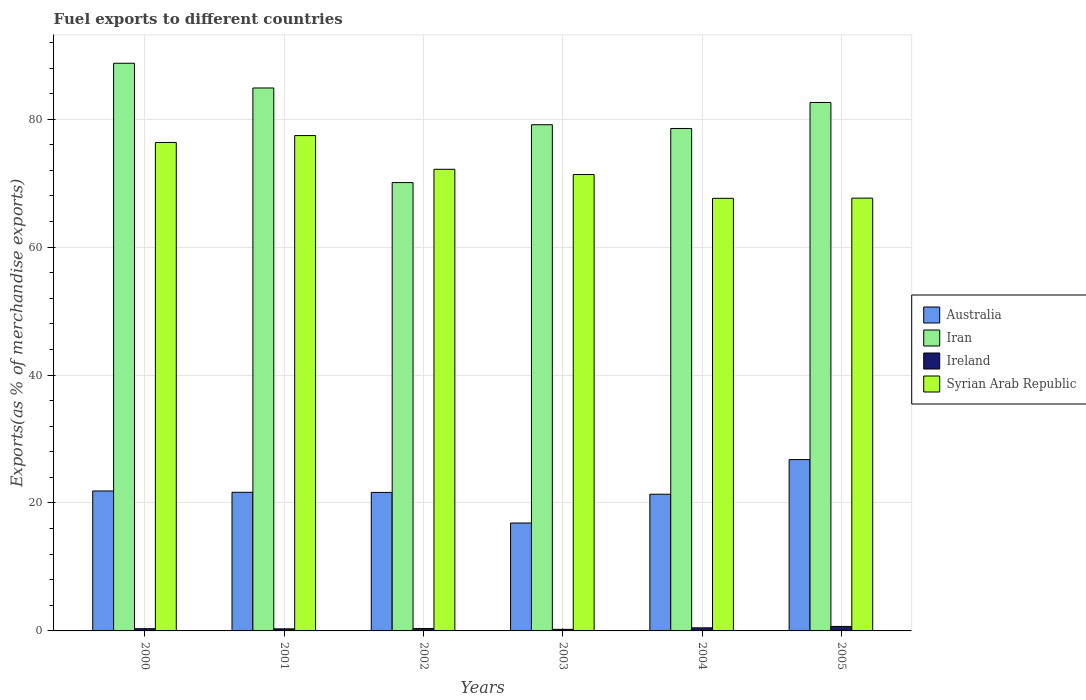How many groups of bars are there?
Offer a very short reply. 6. Are the number of bars per tick equal to the number of legend labels?
Your answer should be very brief. Yes. How many bars are there on the 4th tick from the right?
Offer a very short reply. 4. What is the label of the 6th group of bars from the left?
Keep it short and to the point. 2005. What is the percentage of exports to different countries in Ireland in 2002?
Keep it short and to the point. 0.38. Across all years, what is the maximum percentage of exports to different countries in Australia?
Your response must be concise. 26.79. Across all years, what is the minimum percentage of exports to different countries in Iran?
Offer a terse response. 70.09. In which year was the percentage of exports to different countries in Iran maximum?
Make the answer very short. 2000. What is the total percentage of exports to different countries in Syrian Arab Republic in the graph?
Make the answer very short. 432.6. What is the difference between the percentage of exports to different countries in Iran in 2002 and that in 2003?
Make the answer very short. -9.04. What is the difference between the percentage of exports to different countries in Syrian Arab Republic in 2000 and the percentage of exports to different countries in Ireland in 2002?
Your answer should be very brief. 75.98. What is the average percentage of exports to different countries in Syrian Arab Republic per year?
Your response must be concise. 72.1. In the year 2000, what is the difference between the percentage of exports to different countries in Iran and percentage of exports to different countries in Ireland?
Offer a very short reply. 88.4. In how many years, is the percentage of exports to different countries in Australia greater than 44 %?
Keep it short and to the point. 0. What is the ratio of the percentage of exports to different countries in Ireland in 2004 to that in 2005?
Provide a short and direct response. 0.69. Is the percentage of exports to different countries in Australia in 2001 less than that in 2004?
Offer a terse response. No. What is the difference between the highest and the second highest percentage of exports to different countries in Ireland?
Provide a succinct answer. 0.22. What is the difference between the highest and the lowest percentage of exports to different countries in Iran?
Your answer should be compact. 18.65. What does the 2nd bar from the left in 2000 represents?
Ensure brevity in your answer.  Iran. What does the 1st bar from the right in 2003 represents?
Make the answer very short. Syrian Arab Republic. Is it the case that in every year, the sum of the percentage of exports to different countries in Iran and percentage of exports to different countries in Australia is greater than the percentage of exports to different countries in Ireland?
Your answer should be compact. Yes. How many bars are there?
Provide a succinct answer. 24. Are all the bars in the graph horizontal?
Offer a terse response. No. Are the values on the major ticks of Y-axis written in scientific E-notation?
Ensure brevity in your answer.  No. Does the graph contain any zero values?
Provide a short and direct response. No. Where does the legend appear in the graph?
Provide a short and direct response. Center right. What is the title of the graph?
Make the answer very short. Fuel exports to different countries. Does "Nepal" appear as one of the legend labels in the graph?
Provide a short and direct response. No. What is the label or title of the Y-axis?
Your response must be concise. Exports(as % of merchandise exports). What is the Exports(as % of merchandise exports) in Australia in 2000?
Your answer should be very brief. 21.88. What is the Exports(as % of merchandise exports) of Iran in 2000?
Provide a succinct answer. 88.74. What is the Exports(as % of merchandise exports) in Ireland in 2000?
Offer a very short reply. 0.35. What is the Exports(as % of merchandise exports) of Syrian Arab Republic in 2000?
Give a very brief answer. 76.36. What is the Exports(as % of merchandise exports) in Australia in 2001?
Give a very brief answer. 21.67. What is the Exports(as % of merchandise exports) in Iran in 2001?
Your answer should be compact. 84.88. What is the Exports(as % of merchandise exports) in Ireland in 2001?
Your response must be concise. 0.32. What is the Exports(as % of merchandise exports) in Syrian Arab Republic in 2001?
Provide a succinct answer. 77.44. What is the Exports(as % of merchandise exports) of Australia in 2002?
Offer a very short reply. 21.65. What is the Exports(as % of merchandise exports) in Iran in 2002?
Give a very brief answer. 70.09. What is the Exports(as % of merchandise exports) in Ireland in 2002?
Your response must be concise. 0.38. What is the Exports(as % of merchandise exports) in Syrian Arab Republic in 2002?
Provide a succinct answer. 72.17. What is the Exports(as % of merchandise exports) in Australia in 2003?
Your answer should be very brief. 16.87. What is the Exports(as % of merchandise exports) of Iran in 2003?
Provide a succinct answer. 79.13. What is the Exports(as % of merchandise exports) in Ireland in 2003?
Your answer should be very brief. 0.24. What is the Exports(as % of merchandise exports) in Syrian Arab Republic in 2003?
Give a very brief answer. 71.35. What is the Exports(as % of merchandise exports) in Australia in 2004?
Give a very brief answer. 21.37. What is the Exports(as % of merchandise exports) in Iran in 2004?
Keep it short and to the point. 78.55. What is the Exports(as % of merchandise exports) of Ireland in 2004?
Your answer should be very brief. 0.48. What is the Exports(as % of merchandise exports) in Syrian Arab Republic in 2004?
Offer a very short reply. 67.63. What is the Exports(as % of merchandise exports) in Australia in 2005?
Offer a terse response. 26.79. What is the Exports(as % of merchandise exports) of Iran in 2005?
Your answer should be compact. 82.61. What is the Exports(as % of merchandise exports) in Ireland in 2005?
Give a very brief answer. 0.7. What is the Exports(as % of merchandise exports) of Syrian Arab Republic in 2005?
Keep it short and to the point. 67.66. Across all years, what is the maximum Exports(as % of merchandise exports) in Australia?
Your response must be concise. 26.79. Across all years, what is the maximum Exports(as % of merchandise exports) of Iran?
Your answer should be very brief. 88.74. Across all years, what is the maximum Exports(as % of merchandise exports) of Ireland?
Provide a succinct answer. 0.7. Across all years, what is the maximum Exports(as % of merchandise exports) of Syrian Arab Republic?
Ensure brevity in your answer.  77.44. Across all years, what is the minimum Exports(as % of merchandise exports) in Australia?
Ensure brevity in your answer.  16.87. Across all years, what is the minimum Exports(as % of merchandise exports) in Iran?
Offer a terse response. 70.09. Across all years, what is the minimum Exports(as % of merchandise exports) of Ireland?
Provide a succinct answer. 0.24. Across all years, what is the minimum Exports(as % of merchandise exports) in Syrian Arab Republic?
Provide a succinct answer. 67.63. What is the total Exports(as % of merchandise exports) in Australia in the graph?
Keep it short and to the point. 130.23. What is the total Exports(as % of merchandise exports) in Iran in the graph?
Offer a terse response. 484. What is the total Exports(as % of merchandise exports) of Ireland in the graph?
Give a very brief answer. 2.48. What is the total Exports(as % of merchandise exports) in Syrian Arab Republic in the graph?
Provide a short and direct response. 432.6. What is the difference between the Exports(as % of merchandise exports) of Australia in 2000 and that in 2001?
Ensure brevity in your answer.  0.21. What is the difference between the Exports(as % of merchandise exports) of Iran in 2000 and that in 2001?
Your answer should be compact. 3.86. What is the difference between the Exports(as % of merchandise exports) of Ireland in 2000 and that in 2001?
Offer a terse response. 0.02. What is the difference between the Exports(as % of merchandise exports) of Syrian Arab Republic in 2000 and that in 2001?
Ensure brevity in your answer.  -1.08. What is the difference between the Exports(as % of merchandise exports) in Australia in 2000 and that in 2002?
Make the answer very short. 0.23. What is the difference between the Exports(as % of merchandise exports) in Iran in 2000 and that in 2002?
Your answer should be very brief. 18.65. What is the difference between the Exports(as % of merchandise exports) of Ireland in 2000 and that in 2002?
Keep it short and to the point. -0.04. What is the difference between the Exports(as % of merchandise exports) in Syrian Arab Republic in 2000 and that in 2002?
Your response must be concise. 4.19. What is the difference between the Exports(as % of merchandise exports) of Australia in 2000 and that in 2003?
Your answer should be very brief. 5.01. What is the difference between the Exports(as % of merchandise exports) of Iran in 2000 and that in 2003?
Offer a terse response. 9.61. What is the difference between the Exports(as % of merchandise exports) in Ireland in 2000 and that in 2003?
Make the answer very short. 0.1. What is the difference between the Exports(as % of merchandise exports) in Syrian Arab Republic in 2000 and that in 2003?
Make the answer very short. 5.01. What is the difference between the Exports(as % of merchandise exports) of Australia in 2000 and that in 2004?
Give a very brief answer. 0.51. What is the difference between the Exports(as % of merchandise exports) of Iran in 2000 and that in 2004?
Offer a terse response. 10.2. What is the difference between the Exports(as % of merchandise exports) in Ireland in 2000 and that in 2004?
Give a very brief answer. -0.14. What is the difference between the Exports(as % of merchandise exports) in Syrian Arab Republic in 2000 and that in 2004?
Offer a very short reply. 8.73. What is the difference between the Exports(as % of merchandise exports) in Australia in 2000 and that in 2005?
Ensure brevity in your answer.  -4.91. What is the difference between the Exports(as % of merchandise exports) of Iran in 2000 and that in 2005?
Your answer should be compact. 6.13. What is the difference between the Exports(as % of merchandise exports) in Ireland in 2000 and that in 2005?
Give a very brief answer. -0.35. What is the difference between the Exports(as % of merchandise exports) of Syrian Arab Republic in 2000 and that in 2005?
Make the answer very short. 8.71. What is the difference between the Exports(as % of merchandise exports) in Australia in 2001 and that in 2002?
Keep it short and to the point. 0.02. What is the difference between the Exports(as % of merchandise exports) of Iran in 2001 and that in 2002?
Make the answer very short. 14.79. What is the difference between the Exports(as % of merchandise exports) of Ireland in 2001 and that in 2002?
Give a very brief answer. -0.06. What is the difference between the Exports(as % of merchandise exports) in Syrian Arab Republic in 2001 and that in 2002?
Your response must be concise. 5.27. What is the difference between the Exports(as % of merchandise exports) of Australia in 2001 and that in 2003?
Provide a succinct answer. 4.8. What is the difference between the Exports(as % of merchandise exports) in Iran in 2001 and that in 2003?
Your answer should be compact. 5.74. What is the difference between the Exports(as % of merchandise exports) in Ireland in 2001 and that in 2003?
Make the answer very short. 0.08. What is the difference between the Exports(as % of merchandise exports) in Syrian Arab Republic in 2001 and that in 2003?
Keep it short and to the point. 6.09. What is the difference between the Exports(as % of merchandise exports) of Australia in 2001 and that in 2004?
Offer a very short reply. 0.3. What is the difference between the Exports(as % of merchandise exports) of Iran in 2001 and that in 2004?
Your response must be concise. 6.33. What is the difference between the Exports(as % of merchandise exports) in Ireland in 2001 and that in 2004?
Your answer should be very brief. -0.16. What is the difference between the Exports(as % of merchandise exports) of Syrian Arab Republic in 2001 and that in 2004?
Provide a short and direct response. 9.81. What is the difference between the Exports(as % of merchandise exports) in Australia in 2001 and that in 2005?
Give a very brief answer. -5.11. What is the difference between the Exports(as % of merchandise exports) of Iran in 2001 and that in 2005?
Provide a short and direct response. 2.27. What is the difference between the Exports(as % of merchandise exports) in Ireland in 2001 and that in 2005?
Give a very brief answer. -0.38. What is the difference between the Exports(as % of merchandise exports) in Syrian Arab Republic in 2001 and that in 2005?
Give a very brief answer. 9.78. What is the difference between the Exports(as % of merchandise exports) in Australia in 2002 and that in 2003?
Your response must be concise. 4.78. What is the difference between the Exports(as % of merchandise exports) of Iran in 2002 and that in 2003?
Your answer should be very brief. -9.04. What is the difference between the Exports(as % of merchandise exports) in Ireland in 2002 and that in 2003?
Your answer should be very brief. 0.14. What is the difference between the Exports(as % of merchandise exports) of Syrian Arab Republic in 2002 and that in 2003?
Ensure brevity in your answer.  0.82. What is the difference between the Exports(as % of merchandise exports) of Australia in 2002 and that in 2004?
Offer a terse response. 0.28. What is the difference between the Exports(as % of merchandise exports) of Iran in 2002 and that in 2004?
Provide a short and direct response. -8.46. What is the difference between the Exports(as % of merchandise exports) of Ireland in 2002 and that in 2004?
Your response must be concise. -0.1. What is the difference between the Exports(as % of merchandise exports) in Syrian Arab Republic in 2002 and that in 2004?
Provide a succinct answer. 4.54. What is the difference between the Exports(as % of merchandise exports) in Australia in 2002 and that in 2005?
Your response must be concise. -5.13. What is the difference between the Exports(as % of merchandise exports) in Iran in 2002 and that in 2005?
Ensure brevity in your answer.  -12.52. What is the difference between the Exports(as % of merchandise exports) in Ireland in 2002 and that in 2005?
Give a very brief answer. -0.32. What is the difference between the Exports(as % of merchandise exports) of Syrian Arab Republic in 2002 and that in 2005?
Ensure brevity in your answer.  4.51. What is the difference between the Exports(as % of merchandise exports) in Australia in 2003 and that in 2004?
Your response must be concise. -4.5. What is the difference between the Exports(as % of merchandise exports) in Iran in 2003 and that in 2004?
Offer a terse response. 0.59. What is the difference between the Exports(as % of merchandise exports) in Ireland in 2003 and that in 2004?
Provide a short and direct response. -0.24. What is the difference between the Exports(as % of merchandise exports) of Syrian Arab Republic in 2003 and that in 2004?
Ensure brevity in your answer.  3.72. What is the difference between the Exports(as % of merchandise exports) of Australia in 2003 and that in 2005?
Your answer should be compact. -9.91. What is the difference between the Exports(as % of merchandise exports) in Iran in 2003 and that in 2005?
Provide a short and direct response. -3.48. What is the difference between the Exports(as % of merchandise exports) of Ireland in 2003 and that in 2005?
Your answer should be very brief. -0.46. What is the difference between the Exports(as % of merchandise exports) in Syrian Arab Republic in 2003 and that in 2005?
Provide a short and direct response. 3.69. What is the difference between the Exports(as % of merchandise exports) in Australia in 2004 and that in 2005?
Ensure brevity in your answer.  -5.41. What is the difference between the Exports(as % of merchandise exports) in Iran in 2004 and that in 2005?
Ensure brevity in your answer.  -4.06. What is the difference between the Exports(as % of merchandise exports) in Ireland in 2004 and that in 2005?
Give a very brief answer. -0.22. What is the difference between the Exports(as % of merchandise exports) in Syrian Arab Republic in 2004 and that in 2005?
Keep it short and to the point. -0.03. What is the difference between the Exports(as % of merchandise exports) of Australia in 2000 and the Exports(as % of merchandise exports) of Iran in 2001?
Your answer should be very brief. -63. What is the difference between the Exports(as % of merchandise exports) of Australia in 2000 and the Exports(as % of merchandise exports) of Ireland in 2001?
Provide a short and direct response. 21.56. What is the difference between the Exports(as % of merchandise exports) in Australia in 2000 and the Exports(as % of merchandise exports) in Syrian Arab Republic in 2001?
Make the answer very short. -55.56. What is the difference between the Exports(as % of merchandise exports) in Iran in 2000 and the Exports(as % of merchandise exports) in Ireland in 2001?
Your answer should be very brief. 88.42. What is the difference between the Exports(as % of merchandise exports) of Iran in 2000 and the Exports(as % of merchandise exports) of Syrian Arab Republic in 2001?
Keep it short and to the point. 11.31. What is the difference between the Exports(as % of merchandise exports) in Ireland in 2000 and the Exports(as % of merchandise exports) in Syrian Arab Republic in 2001?
Offer a very short reply. -77.09. What is the difference between the Exports(as % of merchandise exports) of Australia in 2000 and the Exports(as % of merchandise exports) of Iran in 2002?
Your response must be concise. -48.21. What is the difference between the Exports(as % of merchandise exports) of Australia in 2000 and the Exports(as % of merchandise exports) of Ireland in 2002?
Keep it short and to the point. 21.5. What is the difference between the Exports(as % of merchandise exports) of Australia in 2000 and the Exports(as % of merchandise exports) of Syrian Arab Republic in 2002?
Ensure brevity in your answer.  -50.29. What is the difference between the Exports(as % of merchandise exports) in Iran in 2000 and the Exports(as % of merchandise exports) in Ireland in 2002?
Your answer should be compact. 88.36. What is the difference between the Exports(as % of merchandise exports) in Iran in 2000 and the Exports(as % of merchandise exports) in Syrian Arab Republic in 2002?
Keep it short and to the point. 16.58. What is the difference between the Exports(as % of merchandise exports) in Ireland in 2000 and the Exports(as % of merchandise exports) in Syrian Arab Republic in 2002?
Your answer should be compact. -71.82. What is the difference between the Exports(as % of merchandise exports) in Australia in 2000 and the Exports(as % of merchandise exports) in Iran in 2003?
Offer a very short reply. -57.25. What is the difference between the Exports(as % of merchandise exports) in Australia in 2000 and the Exports(as % of merchandise exports) in Ireland in 2003?
Keep it short and to the point. 21.64. What is the difference between the Exports(as % of merchandise exports) in Australia in 2000 and the Exports(as % of merchandise exports) in Syrian Arab Republic in 2003?
Keep it short and to the point. -49.47. What is the difference between the Exports(as % of merchandise exports) in Iran in 2000 and the Exports(as % of merchandise exports) in Ireland in 2003?
Ensure brevity in your answer.  88.5. What is the difference between the Exports(as % of merchandise exports) of Iran in 2000 and the Exports(as % of merchandise exports) of Syrian Arab Republic in 2003?
Keep it short and to the point. 17.4. What is the difference between the Exports(as % of merchandise exports) of Ireland in 2000 and the Exports(as % of merchandise exports) of Syrian Arab Republic in 2003?
Provide a short and direct response. -71. What is the difference between the Exports(as % of merchandise exports) of Australia in 2000 and the Exports(as % of merchandise exports) of Iran in 2004?
Offer a very short reply. -56.67. What is the difference between the Exports(as % of merchandise exports) of Australia in 2000 and the Exports(as % of merchandise exports) of Ireland in 2004?
Your answer should be compact. 21.4. What is the difference between the Exports(as % of merchandise exports) in Australia in 2000 and the Exports(as % of merchandise exports) in Syrian Arab Republic in 2004?
Keep it short and to the point. -45.75. What is the difference between the Exports(as % of merchandise exports) in Iran in 2000 and the Exports(as % of merchandise exports) in Ireland in 2004?
Provide a succinct answer. 88.26. What is the difference between the Exports(as % of merchandise exports) of Iran in 2000 and the Exports(as % of merchandise exports) of Syrian Arab Republic in 2004?
Your answer should be compact. 21.11. What is the difference between the Exports(as % of merchandise exports) of Ireland in 2000 and the Exports(as % of merchandise exports) of Syrian Arab Republic in 2004?
Offer a very short reply. -67.28. What is the difference between the Exports(as % of merchandise exports) of Australia in 2000 and the Exports(as % of merchandise exports) of Iran in 2005?
Offer a terse response. -60.73. What is the difference between the Exports(as % of merchandise exports) in Australia in 2000 and the Exports(as % of merchandise exports) in Ireland in 2005?
Give a very brief answer. 21.18. What is the difference between the Exports(as % of merchandise exports) of Australia in 2000 and the Exports(as % of merchandise exports) of Syrian Arab Republic in 2005?
Make the answer very short. -45.78. What is the difference between the Exports(as % of merchandise exports) of Iran in 2000 and the Exports(as % of merchandise exports) of Ireland in 2005?
Provide a short and direct response. 88.04. What is the difference between the Exports(as % of merchandise exports) in Iran in 2000 and the Exports(as % of merchandise exports) in Syrian Arab Republic in 2005?
Provide a succinct answer. 21.09. What is the difference between the Exports(as % of merchandise exports) in Ireland in 2000 and the Exports(as % of merchandise exports) in Syrian Arab Republic in 2005?
Your answer should be very brief. -67.31. What is the difference between the Exports(as % of merchandise exports) in Australia in 2001 and the Exports(as % of merchandise exports) in Iran in 2002?
Ensure brevity in your answer.  -48.42. What is the difference between the Exports(as % of merchandise exports) of Australia in 2001 and the Exports(as % of merchandise exports) of Ireland in 2002?
Keep it short and to the point. 21.29. What is the difference between the Exports(as % of merchandise exports) in Australia in 2001 and the Exports(as % of merchandise exports) in Syrian Arab Republic in 2002?
Your answer should be very brief. -50.5. What is the difference between the Exports(as % of merchandise exports) of Iran in 2001 and the Exports(as % of merchandise exports) of Ireland in 2002?
Provide a short and direct response. 84.49. What is the difference between the Exports(as % of merchandise exports) of Iran in 2001 and the Exports(as % of merchandise exports) of Syrian Arab Republic in 2002?
Ensure brevity in your answer.  12.71. What is the difference between the Exports(as % of merchandise exports) in Ireland in 2001 and the Exports(as % of merchandise exports) in Syrian Arab Republic in 2002?
Offer a terse response. -71.84. What is the difference between the Exports(as % of merchandise exports) of Australia in 2001 and the Exports(as % of merchandise exports) of Iran in 2003?
Your answer should be compact. -57.46. What is the difference between the Exports(as % of merchandise exports) in Australia in 2001 and the Exports(as % of merchandise exports) in Ireland in 2003?
Provide a succinct answer. 21.43. What is the difference between the Exports(as % of merchandise exports) of Australia in 2001 and the Exports(as % of merchandise exports) of Syrian Arab Republic in 2003?
Your answer should be very brief. -49.68. What is the difference between the Exports(as % of merchandise exports) of Iran in 2001 and the Exports(as % of merchandise exports) of Ireland in 2003?
Offer a terse response. 84.63. What is the difference between the Exports(as % of merchandise exports) of Iran in 2001 and the Exports(as % of merchandise exports) of Syrian Arab Republic in 2003?
Make the answer very short. 13.53. What is the difference between the Exports(as % of merchandise exports) in Ireland in 2001 and the Exports(as % of merchandise exports) in Syrian Arab Republic in 2003?
Ensure brevity in your answer.  -71.02. What is the difference between the Exports(as % of merchandise exports) in Australia in 2001 and the Exports(as % of merchandise exports) in Iran in 2004?
Provide a short and direct response. -56.88. What is the difference between the Exports(as % of merchandise exports) of Australia in 2001 and the Exports(as % of merchandise exports) of Ireland in 2004?
Give a very brief answer. 21.19. What is the difference between the Exports(as % of merchandise exports) in Australia in 2001 and the Exports(as % of merchandise exports) in Syrian Arab Republic in 2004?
Ensure brevity in your answer.  -45.96. What is the difference between the Exports(as % of merchandise exports) in Iran in 2001 and the Exports(as % of merchandise exports) in Ireland in 2004?
Provide a short and direct response. 84.4. What is the difference between the Exports(as % of merchandise exports) in Iran in 2001 and the Exports(as % of merchandise exports) in Syrian Arab Republic in 2004?
Your response must be concise. 17.25. What is the difference between the Exports(as % of merchandise exports) in Ireland in 2001 and the Exports(as % of merchandise exports) in Syrian Arab Republic in 2004?
Give a very brief answer. -67.31. What is the difference between the Exports(as % of merchandise exports) in Australia in 2001 and the Exports(as % of merchandise exports) in Iran in 2005?
Give a very brief answer. -60.94. What is the difference between the Exports(as % of merchandise exports) in Australia in 2001 and the Exports(as % of merchandise exports) in Ireland in 2005?
Keep it short and to the point. 20.97. What is the difference between the Exports(as % of merchandise exports) in Australia in 2001 and the Exports(as % of merchandise exports) in Syrian Arab Republic in 2005?
Provide a succinct answer. -45.99. What is the difference between the Exports(as % of merchandise exports) of Iran in 2001 and the Exports(as % of merchandise exports) of Ireland in 2005?
Give a very brief answer. 84.18. What is the difference between the Exports(as % of merchandise exports) in Iran in 2001 and the Exports(as % of merchandise exports) in Syrian Arab Republic in 2005?
Your response must be concise. 17.22. What is the difference between the Exports(as % of merchandise exports) in Ireland in 2001 and the Exports(as % of merchandise exports) in Syrian Arab Republic in 2005?
Offer a very short reply. -67.33. What is the difference between the Exports(as % of merchandise exports) in Australia in 2002 and the Exports(as % of merchandise exports) in Iran in 2003?
Your answer should be compact. -57.48. What is the difference between the Exports(as % of merchandise exports) in Australia in 2002 and the Exports(as % of merchandise exports) in Ireland in 2003?
Ensure brevity in your answer.  21.41. What is the difference between the Exports(as % of merchandise exports) in Australia in 2002 and the Exports(as % of merchandise exports) in Syrian Arab Republic in 2003?
Your response must be concise. -49.69. What is the difference between the Exports(as % of merchandise exports) in Iran in 2002 and the Exports(as % of merchandise exports) in Ireland in 2003?
Make the answer very short. 69.85. What is the difference between the Exports(as % of merchandise exports) in Iran in 2002 and the Exports(as % of merchandise exports) in Syrian Arab Republic in 2003?
Provide a short and direct response. -1.26. What is the difference between the Exports(as % of merchandise exports) in Ireland in 2002 and the Exports(as % of merchandise exports) in Syrian Arab Republic in 2003?
Ensure brevity in your answer.  -70.96. What is the difference between the Exports(as % of merchandise exports) of Australia in 2002 and the Exports(as % of merchandise exports) of Iran in 2004?
Your response must be concise. -56.89. What is the difference between the Exports(as % of merchandise exports) in Australia in 2002 and the Exports(as % of merchandise exports) in Ireland in 2004?
Make the answer very short. 21.17. What is the difference between the Exports(as % of merchandise exports) of Australia in 2002 and the Exports(as % of merchandise exports) of Syrian Arab Republic in 2004?
Provide a succinct answer. -45.98. What is the difference between the Exports(as % of merchandise exports) in Iran in 2002 and the Exports(as % of merchandise exports) in Ireland in 2004?
Your response must be concise. 69.61. What is the difference between the Exports(as % of merchandise exports) in Iran in 2002 and the Exports(as % of merchandise exports) in Syrian Arab Republic in 2004?
Your answer should be very brief. 2.46. What is the difference between the Exports(as % of merchandise exports) of Ireland in 2002 and the Exports(as % of merchandise exports) of Syrian Arab Republic in 2004?
Ensure brevity in your answer.  -67.25. What is the difference between the Exports(as % of merchandise exports) in Australia in 2002 and the Exports(as % of merchandise exports) in Iran in 2005?
Give a very brief answer. -60.96. What is the difference between the Exports(as % of merchandise exports) in Australia in 2002 and the Exports(as % of merchandise exports) in Ireland in 2005?
Provide a succinct answer. 20.95. What is the difference between the Exports(as % of merchandise exports) of Australia in 2002 and the Exports(as % of merchandise exports) of Syrian Arab Republic in 2005?
Your response must be concise. -46. What is the difference between the Exports(as % of merchandise exports) in Iran in 2002 and the Exports(as % of merchandise exports) in Ireland in 2005?
Offer a terse response. 69.39. What is the difference between the Exports(as % of merchandise exports) in Iran in 2002 and the Exports(as % of merchandise exports) in Syrian Arab Republic in 2005?
Ensure brevity in your answer.  2.43. What is the difference between the Exports(as % of merchandise exports) in Ireland in 2002 and the Exports(as % of merchandise exports) in Syrian Arab Republic in 2005?
Provide a short and direct response. -67.27. What is the difference between the Exports(as % of merchandise exports) of Australia in 2003 and the Exports(as % of merchandise exports) of Iran in 2004?
Keep it short and to the point. -61.68. What is the difference between the Exports(as % of merchandise exports) of Australia in 2003 and the Exports(as % of merchandise exports) of Ireland in 2004?
Provide a succinct answer. 16.39. What is the difference between the Exports(as % of merchandise exports) of Australia in 2003 and the Exports(as % of merchandise exports) of Syrian Arab Republic in 2004?
Provide a short and direct response. -50.76. What is the difference between the Exports(as % of merchandise exports) in Iran in 2003 and the Exports(as % of merchandise exports) in Ireland in 2004?
Provide a succinct answer. 78.65. What is the difference between the Exports(as % of merchandise exports) of Iran in 2003 and the Exports(as % of merchandise exports) of Syrian Arab Republic in 2004?
Provide a short and direct response. 11.5. What is the difference between the Exports(as % of merchandise exports) in Ireland in 2003 and the Exports(as % of merchandise exports) in Syrian Arab Republic in 2004?
Your answer should be compact. -67.38. What is the difference between the Exports(as % of merchandise exports) of Australia in 2003 and the Exports(as % of merchandise exports) of Iran in 2005?
Offer a very short reply. -65.74. What is the difference between the Exports(as % of merchandise exports) of Australia in 2003 and the Exports(as % of merchandise exports) of Ireland in 2005?
Provide a succinct answer. 16.17. What is the difference between the Exports(as % of merchandise exports) of Australia in 2003 and the Exports(as % of merchandise exports) of Syrian Arab Republic in 2005?
Your answer should be very brief. -50.79. What is the difference between the Exports(as % of merchandise exports) in Iran in 2003 and the Exports(as % of merchandise exports) in Ireland in 2005?
Keep it short and to the point. 78.43. What is the difference between the Exports(as % of merchandise exports) of Iran in 2003 and the Exports(as % of merchandise exports) of Syrian Arab Republic in 2005?
Provide a short and direct response. 11.48. What is the difference between the Exports(as % of merchandise exports) of Ireland in 2003 and the Exports(as % of merchandise exports) of Syrian Arab Republic in 2005?
Your answer should be very brief. -67.41. What is the difference between the Exports(as % of merchandise exports) in Australia in 2004 and the Exports(as % of merchandise exports) in Iran in 2005?
Make the answer very short. -61.24. What is the difference between the Exports(as % of merchandise exports) of Australia in 2004 and the Exports(as % of merchandise exports) of Ireland in 2005?
Provide a short and direct response. 20.67. What is the difference between the Exports(as % of merchandise exports) of Australia in 2004 and the Exports(as % of merchandise exports) of Syrian Arab Republic in 2005?
Give a very brief answer. -46.28. What is the difference between the Exports(as % of merchandise exports) of Iran in 2004 and the Exports(as % of merchandise exports) of Ireland in 2005?
Provide a short and direct response. 77.85. What is the difference between the Exports(as % of merchandise exports) in Iran in 2004 and the Exports(as % of merchandise exports) in Syrian Arab Republic in 2005?
Provide a short and direct response. 10.89. What is the difference between the Exports(as % of merchandise exports) of Ireland in 2004 and the Exports(as % of merchandise exports) of Syrian Arab Republic in 2005?
Your answer should be compact. -67.17. What is the average Exports(as % of merchandise exports) of Australia per year?
Make the answer very short. 21.71. What is the average Exports(as % of merchandise exports) of Iran per year?
Give a very brief answer. 80.67. What is the average Exports(as % of merchandise exports) in Ireland per year?
Provide a succinct answer. 0.41. What is the average Exports(as % of merchandise exports) in Syrian Arab Republic per year?
Your answer should be compact. 72.1. In the year 2000, what is the difference between the Exports(as % of merchandise exports) of Australia and Exports(as % of merchandise exports) of Iran?
Provide a short and direct response. -66.86. In the year 2000, what is the difference between the Exports(as % of merchandise exports) in Australia and Exports(as % of merchandise exports) in Ireland?
Offer a terse response. 21.53. In the year 2000, what is the difference between the Exports(as % of merchandise exports) in Australia and Exports(as % of merchandise exports) in Syrian Arab Republic?
Offer a terse response. -54.48. In the year 2000, what is the difference between the Exports(as % of merchandise exports) in Iran and Exports(as % of merchandise exports) in Ireland?
Offer a very short reply. 88.4. In the year 2000, what is the difference between the Exports(as % of merchandise exports) of Iran and Exports(as % of merchandise exports) of Syrian Arab Republic?
Make the answer very short. 12.38. In the year 2000, what is the difference between the Exports(as % of merchandise exports) of Ireland and Exports(as % of merchandise exports) of Syrian Arab Republic?
Offer a terse response. -76.02. In the year 2001, what is the difference between the Exports(as % of merchandise exports) in Australia and Exports(as % of merchandise exports) in Iran?
Offer a terse response. -63.21. In the year 2001, what is the difference between the Exports(as % of merchandise exports) of Australia and Exports(as % of merchandise exports) of Ireland?
Provide a short and direct response. 21.35. In the year 2001, what is the difference between the Exports(as % of merchandise exports) in Australia and Exports(as % of merchandise exports) in Syrian Arab Republic?
Make the answer very short. -55.77. In the year 2001, what is the difference between the Exports(as % of merchandise exports) of Iran and Exports(as % of merchandise exports) of Ireland?
Offer a very short reply. 84.55. In the year 2001, what is the difference between the Exports(as % of merchandise exports) of Iran and Exports(as % of merchandise exports) of Syrian Arab Republic?
Keep it short and to the point. 7.44. In the year 2001, what is the difference between the Exports(as % of merchandise exports) of Ireland and Exports(as % of merchandise exports) of Syrian Arab Republic?
Your answer should be compact. -77.11. In the year 2002, what is the difference between the Exports(as % of merchandise exports) of Australia and Exports(as % of merchandise exports) of Iran?
Your answer should be compact. -48.44. In the year 2002, what is the difference between the Exports(as % of merchandise exports) in Australia and Exports(as % of merchandise exports) in Ireland?
Give a very brief answer. 21.27. In the year 2002, what is the difference between the Exports(as % of merchandise exports) in Australia and Exports(as % of merchandise exports) in Syrian Arab Republic?
Your answer should be compact. -50.51. In the year 2002, what is the difference between the Exports(as % of merchandise exports) in Iran and Exports(as % of merchandise exports) in Ireland?
Keep it short and to the point. 69.71. In the year 2002, what is the difference between the Exports(as % of merchandise exports) of Iran and Exports(as % of merchandise exports) of Syrian Arab Republic?
Make the answer very short. -2.08. In the year 2002, what is the difference between the Exports(as % of merchandise exports) of Ireland and Exports(as % of merchandise exports) of Syrian Arab Republic?
Offer a terse response. -71.78. In the year 2003, what is the difference between the Exports(as % of merchandise exports) of Australia and Exports(as % of merchandise exports) of Iran?
Provide a succinct answer. -62.26. In the year 2003, what is the difference between the Exports(as % of merchandise exports) in Australia and Exports(as % of merchandise exports) in Ireland?
Offer a terse response. 16.63. In the year 2003, what is the difference between the Exports(as % of merchandise exports) of Australia and Exports(as % of merchandise exports) of Syrian Arab Republic?
Offer a very short reply. -54.48. In the year 2003, what is the difference between the Exports(as % of merchandise exports) in Iran and Exports(as % of merchandise exports) in Ireland?
Your response must be concise. 78.89. In the year 2003, what is the difference between the Exports(as % of merchandise exports) in Iran and Exports(as % of merchandise exports) in Syrian Arab Republic?
Offer a very short reply. 7.79. In the year 2003, what is the difference between the Exports(as % of merchandise exports) in Ireland and Exports(as % of merchandise exports) in Syrian Arab Republic?
Ensure brevity in your answer.  -71.1. In the year 2004, what is the difference between the Exports(as % of merchandise exports) in Australia and Exports(as % of merchandise exports) in Iran?
Give a very brief answer. -57.17. In the year 2004, what is the difference between the Exports(as % of merchandise exports) of Australia and Exports(as % of merchandise exports) of Ireland?
Your answer should be very brief. 20.89. In the year 2004, what is the difference between the Exports(as % of merchandise exports) of Australia and Exports(as % of merchandise exports) of Syrian Arab Republic?
Ensure brevity in your answer.  -46.26. In the year 2004, what is the difference between the Exports(as % of merchandise exports) in Iran and Exports(as % of merchandise exports) in Ireland?
Provide a short and direct response. 78.06. In the year 2004, what is the difference between the Exports(as % of merchandise exports) in Iran and Exports(as % of merchandise exports) in Syrian Arab Republic?
Ensure brevity in your answer.  10.92. In the year 2004, what is the difference between the Exports(as % of merchandise exports) of Ireland and Exports(as % of merchandise exports) of Syrian Arab Republic?
Your answer should be very brief. -67.15. In the year 2005, what is the difference between the Exports(as % of merchandise exports) of Australia and Exports(as % of merchandise exports) of Iran?
Provide a short and direct response. -55.83. In the year 2005, what is the difference between the Exports(as % of merchandise exports) in Australia and Exports(as % of merchandise exports) in Ireland?
Offer a terse response. 26.08. In the year 2005, what is the difference between the Exports(as % of merchandise exports) in Australia and Exports(as % of merchandise exports) in Syrian Arab Republic?
Give a very brief answer. -40.87. In the year 2005, what is the difference between the Exports(as % of merchandise exports) in Iran and Exports(as % of merchandise exports) in Ireland?
Make the answer very short. 81.91. In the year 2005, what is the difference between the Exports(as % of merchandise exports) in Iran and Exports(as % of merchandise exports) in Syrian Arab Republic?
Offer a very short reply. 14.95. In the year 2005, what is the difference between the Exports(as % of merchandise exports) in Ireland and Exports(as % of merchandise exports) in Syrian Arab Republic?
Your response must be concise. -66.96. What is the ratio of the Exports(as % of merchandise exports) in Australia in 2000 to that in 2001?
Make the answer very short. 1.01. What is the ratio of the Exports(as % of merchandise exports) of Iran in 2000 to that in 2001?
Keep it short and to the point. 1.05. What is the ratio of the Exports(as % of merchandise exports) in Ireland in 2000 to that in 2001?
Make the answer very short. 1.07. What is the ratio of the Exports(as % of merchandise exports) of Syrian Arab Republic in 2000 to that in 2001?
Make the answer very short. 0.99. What is the ratio of the Exports(as % of merchandise exports) of Australia in 2000 to that in 2002?
Give a very brief answer. 1.01. What is the ratio of the Exports(as % of merchandise exports) of Iran in 2000 to that in 2002?
Provide a short and direct response. 1.27. What is the ratio of the Exports(as % of merchandise exports) in Ireland in 2000 to that in 2002?
Offer a very short reply. 0.9. What is the ratio of the Exports(as % of merchandise exports) in Syrian Arab Republic in 2000 to that in 2002?
Make the answer very short. 1.06. What is the ratio of the Exports(as % of merchandise exports) of Australia in 2000 to that in 2003?
Keep it short and to the point. 1.3. What is the ratio of the Exports(as % of merchandise exports) of Iran in 2000 to that in 2003?
Provide a succinct answer. 1.12. What is the ratio of the Exports(as % of merchandise exports) of Ireland in 2000 to that in 2003?
Your answer should be very brief. 1.41. What is the ratio of the Exports(as % of merchandise exports) of Syrian Arab Republic in 2000 to that in 2003?
Make the answer very short. 1.07. What is the ratio of the Exports(as % of merchandise exports) in Australia in 2000 to that in 2004?
Give a very brief answer. 1.02. What is the ratio of the Exports(as % of merchandise exports) of Iran in 2000 to that in 2004?
Keep it short and to the point. 1.13. What is the ratio of the Exports(as % of merchandise exports) of Ireland in 2000 to that in 2004?
Make the answer very short. 0.72. What is the ratio of the Exports(as % of merchandise exports) of Syrian Arab Republic in 2000 to that in 2004?
Provide a short and direct response. 1.13. What is the ratio of the Exports(as % of merchandise exports) of Australia in 2000 to that in 2005?
Keep it short and to the point. 0.82. What is the ratio of the Exports(as % of merchandise exports) of Iran in 2000 to that in 2005?
Keep it short and to the point. 1.07. What is the ratio of the Exports(as % of merchandise exports) in Ireland in 2000 to that in 2005?
Your answer should be very brief. 0.49. What is the ratio of the Exports(as % of merchandise exports) of Syrian Arab Republic in 2000 to that in 2005?
Your answer should be compact. 1.13. What is the ratio of the Exports(as % of merchandise exports) in Australia in 2001 to that in 2002?
Provide a short and direct response. 1. What is the ratio of the Exports(as % of merchandise exports) of Iran in 2001 to that in 2002?
Provide a short and direct response. 1.21. What is the ratio of the Exports(as % of merchandise exports) of Ireland in 2001 to that in 2002?
Your answer should be compact. 0.84. What is the ratio of the Exports(as % of merchandise exports) in Syrian Arab Republic in 2001 to that in 2002?
Your response must be concise. 1.07. What is the ratio of the Exports(as % of merchandise exports) in Australia in 2001 to that in 2003?
Give a very brief answer. 1.28. What is the ratio of the Exports(as % of merchandise exports) of Iran in 2001 to that in 2003?
Your answer should be very brief. 1.07. What is the ratio of the Exports(as % of merchandise exports) of Ireland in 2001 to that in 2003?
Your response must be concise. 1.32. What is the ratio of the Exports(as % of merchandise exports) of Syrian Arab Republic in 2001 to that in 2003?
Your response must be concise. 1.09. What is the ratio of the Exports(as % of merchandise exports) in Iran in 2001 to that in 2004?
Provide a short and direct response. 1.08. What is the ratio of the Exports(as % of merchandise exports) in Ireland in 2001 to that in 2004?
Your answer should be very brief. 0.67. What is the ratio of the Exports(as % of merchandise exports) of Syrian Arab Republic in 2001 to that in 2004?
Keep it short and to the point. 1.15. What is the ratio of the Exports(as % of merchandise exports) in Australia in 2001 to that in 2005?
Your response must be concise. 0.81. What is the ratio of the Exports(as % of merchandise exports) of Iran in 2001 to that in 2005?
Keep it short and to the point. 1.03. What is the ratio of the Exports(as % of merchandise exports) of Ireland in 2001 to that in 2005?
Your response must be concise. 0.46. What is the ratio of the Exports(as % of merchandise exports) in Syrian Arab Republic in 2001 to that in 2005?
Offer a terse response. 1.14. What is the ratio of the Exports(as % of merchandise exports) of Australia in 2002 to that in 2003?
Give a very brief answer. 1.28. What is the ratio of the Exports(as % of merchandise exports) of Iran in 2002 to that in 2003?
Your answer should be very brief. 0.89. What is the ratio of the Exports(as % of merchandise exports) of Ireland in 2002 to that in 2003?
Ensure brevity in your answer.  1.56. What is the ratio of the Exports(as % of merchandise exports) of Syrian Arab Republic in 2002 to that in 2003?
Your answer should be very brief. 1.01. What is the ratio of the Exports(as % of merchandise exports) of Australia in 2002 to that in 2004?
Your answer should be very brief. 1.01. What is the ratio of the Exports(as % of merchandise exports) in Iran in 2002 to that in 2004?
Provide a succinct answer. 0.89. What is the ratio of the Exports(as % of merchandise exports) of Ireland in 2002 to that in 2004?
Your response must be concise. 0.79. What is the ratio of the Exports(as % of merchandise exports) in Syrian Arab Republic in 2002 to that in 2004?
Ensure brevity in your answer.  1.07. What is the ratio of the Exports(as % of merchandise exports) of Australia in 2002 to that in 2005?
Your answer should be compact. 0.81. What is the ratio of the Exports(as % of merchandise exports) in Iran in 2002 to that in 2005?
Offer a very short reply. 0.85. What is the ratio of the Exports(as % of merchandise exports) of Ireland in 2002 to that in 2005?
Ensure brevity in your answer.  0.55. What is the ratio of the Exports(as % of merchandise exports) of Syrian Arab Republic in 2002 to that in 2005?
Your answer should be very brief. 1.07. What is the ratio of the Exports(as % of merchandise exports) in Australia in 2003 to that in 2004?
Offer a terse response. 0.79. What is the ratio of the Exports(as % of merchandise exports) in Iran in 2003 to that in 2004?
Provide a short and direct response. 1.01. What is the ratio of the Exports(as % of merchandise exports) of Ireland in 2003 to that in 2004?
Your answer should be compact. 0.51. What is the ratio of the Exports(as % of merchandise exports) in Syrian Arab Republic in 2003 to that in 2004?
Your answer should be very brief. 1.05. What is the ratio of the Exports(as % of merchandise exports) of Australia in 2003 to that in 2005?
Make the answer very short. 0.63. What is the ratio of the Exports(as % of merchandise exports) in Iran in 2003 to that in 2005?
Offer a very short reply. 0.96. What is the ratio of the Exports(as % of merchandise exports) of Ireland in 2003 to that in 2005?
Make the answer very short. 0.35. What is the ratio of the Exports(as % of merchandise exports) in Syrian Arab Republic in 2003 to that in 2005?
Keep it short and to the point. 1.05. What is the ratio of the Exports(as % of merchandise exports) in Australia in 2004 to that in 2005?
Offer a very short reply. 0.8. What is the ratio of the Exports(as % of merchandise exports) of Iran in 2004 to that in 2005?
Provide a succinct answer. 0.95. What is the ratio of the Exports(as % of merchandise exports) of Ireland in 2004 to that in 2005?
Provide a succinct answer. 0.69. What is the difference between the highest and the second highest Exports(as % of merchandise exports) of Australia?
Your answer should be compact. 4.91. What is the difference between the highest and the second highest Exports(as % of merchandise exports) of Iran?
Give a very brief answer. 3.86. What is the difference between the highest and the second highest Exports(as % of merchandise exports) of Ireland?
Provide a short and direct response. 0.22. What is the difference between the highest and the second highest Exports(as % of merchandise exports) of Syrian Arab Republic?
Provide a short and direct response. 1.08. What is the difference between the highest and the lowest Exports(as % of merchandise exports) of Australia?
Give a very brief answer. 9.91. What is the difference between the highest and the lowest Exports(as % of merchandise exports) of Iran?
Your answer should be compact. 18.65. What is the difference between the highest and the lowest Exports(as % of merchandise exports) of Ireland?
Make the answer very short. 0.46. What is the difference between the highest and the lowest Exports(as % of merchandise exports) in Syrian Arab Republic?
Offer a very short reply. 9.81. 